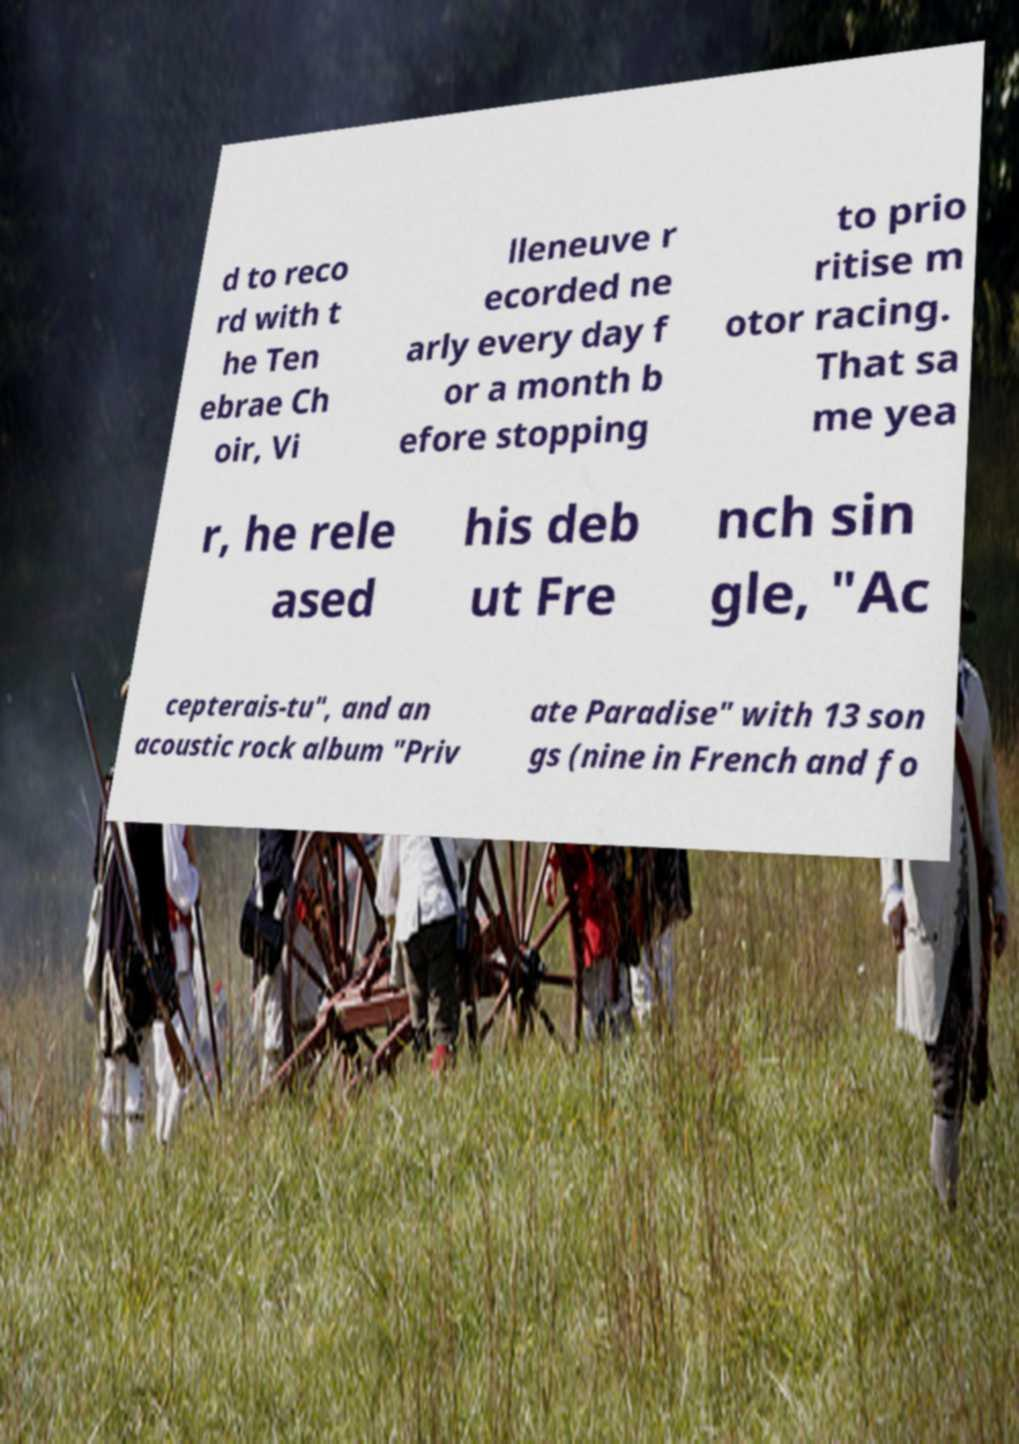Can you accurately transcribe the text from the provided image for me? d to reco rd with t he Ten ebrae Ch oir, Vi lleneuve r ecorded ne arly every day f or a month b efore stopping to prio ritise m otor racing. That sa me yea r, he rele ased his deb ut Fre nch sin gle, "Ac cepterais-tu", and an acoustic rock album "Priv ate Paradise" with 13 son gs (nine in French and fo 